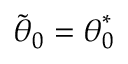Convert formula to latex. <formula><loc_0><loc_0><loc_500><loc_500>\tilde { \theta } _ { 0 } = { \theta } _ { 0 } ^ { * }</formula> 